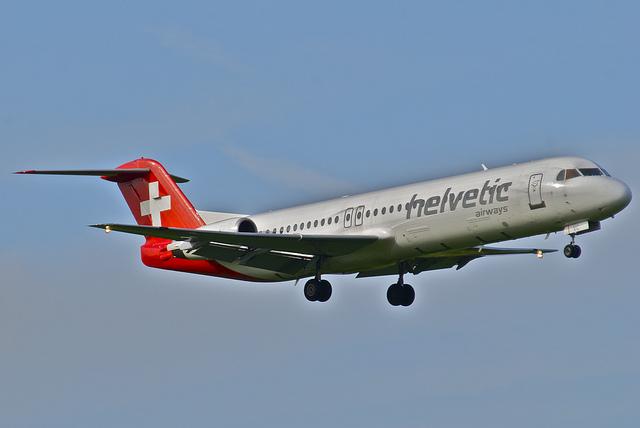What color are the words on the plane?
Answer briefly. Gray. Is this a Swiss plane?
Write a very short answer. Yes. How many jets are there?
Short answer required. 1. What is the name of the plane?
Short answer required. Helvetic. Is the plane taking off or landing?
Short answer required. Landing. Is the plane landing?
Short answer required. No. What type of airplane is this?
Keep it brief. Helvetic. 